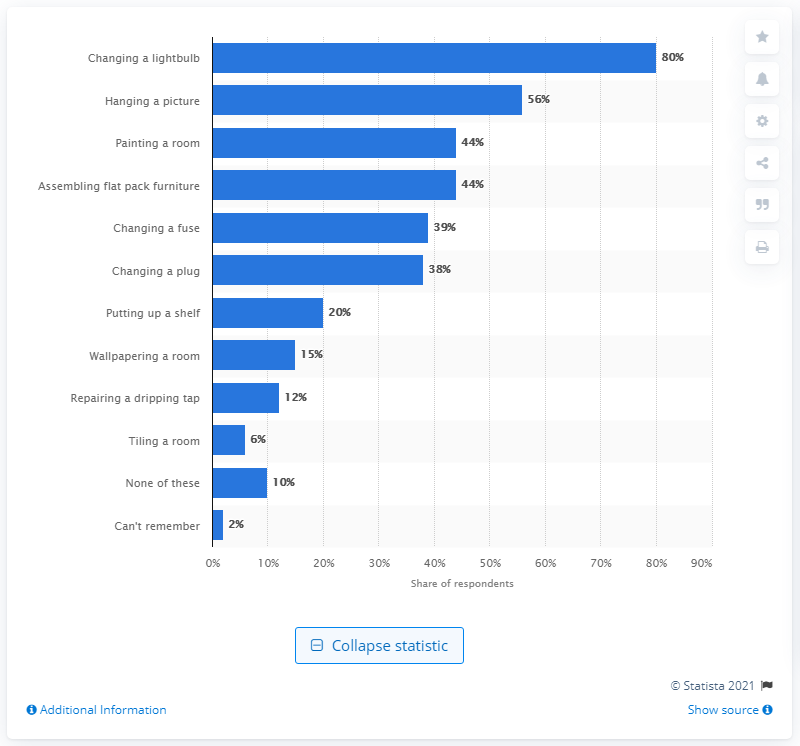Outline some significant characteristics in this image. It was found that tiling a room was the least common DIY activity performed by adults in their homes. 